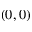<formula> <loc_0><loc_0><loc_500><loc_500>( 0 , 0 )</formula> 